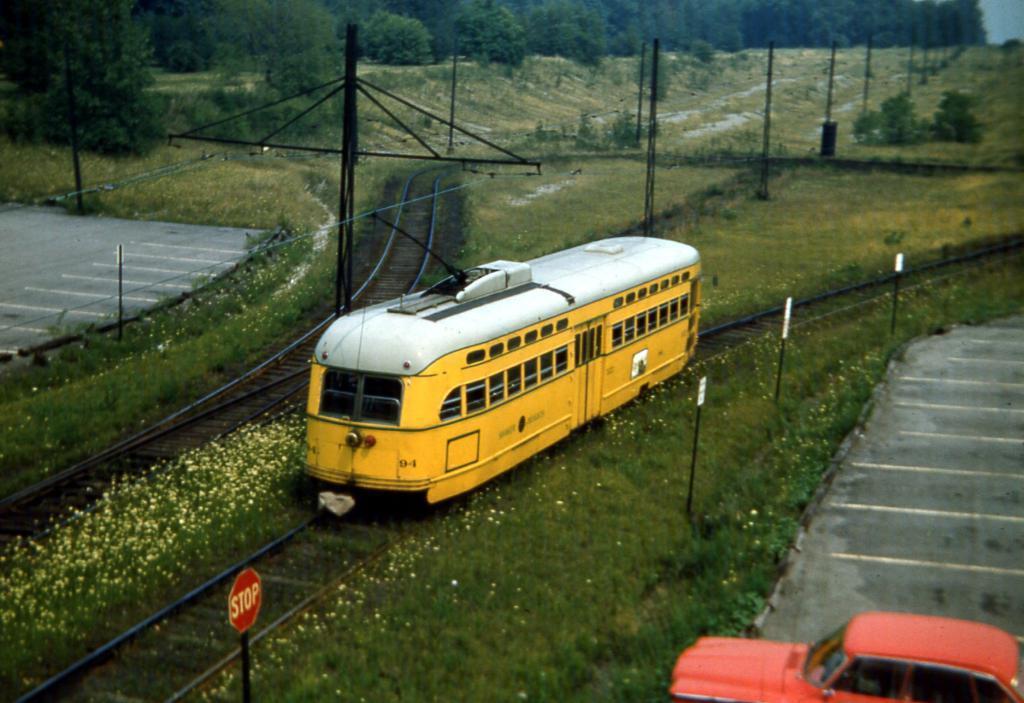Please provide a concise description of this image. In this picture I can see a car on the right bottom and in the middle of this picture I see the roads, plants, flowers, tracks, train, few boards, poles and in the background I see the trees. 